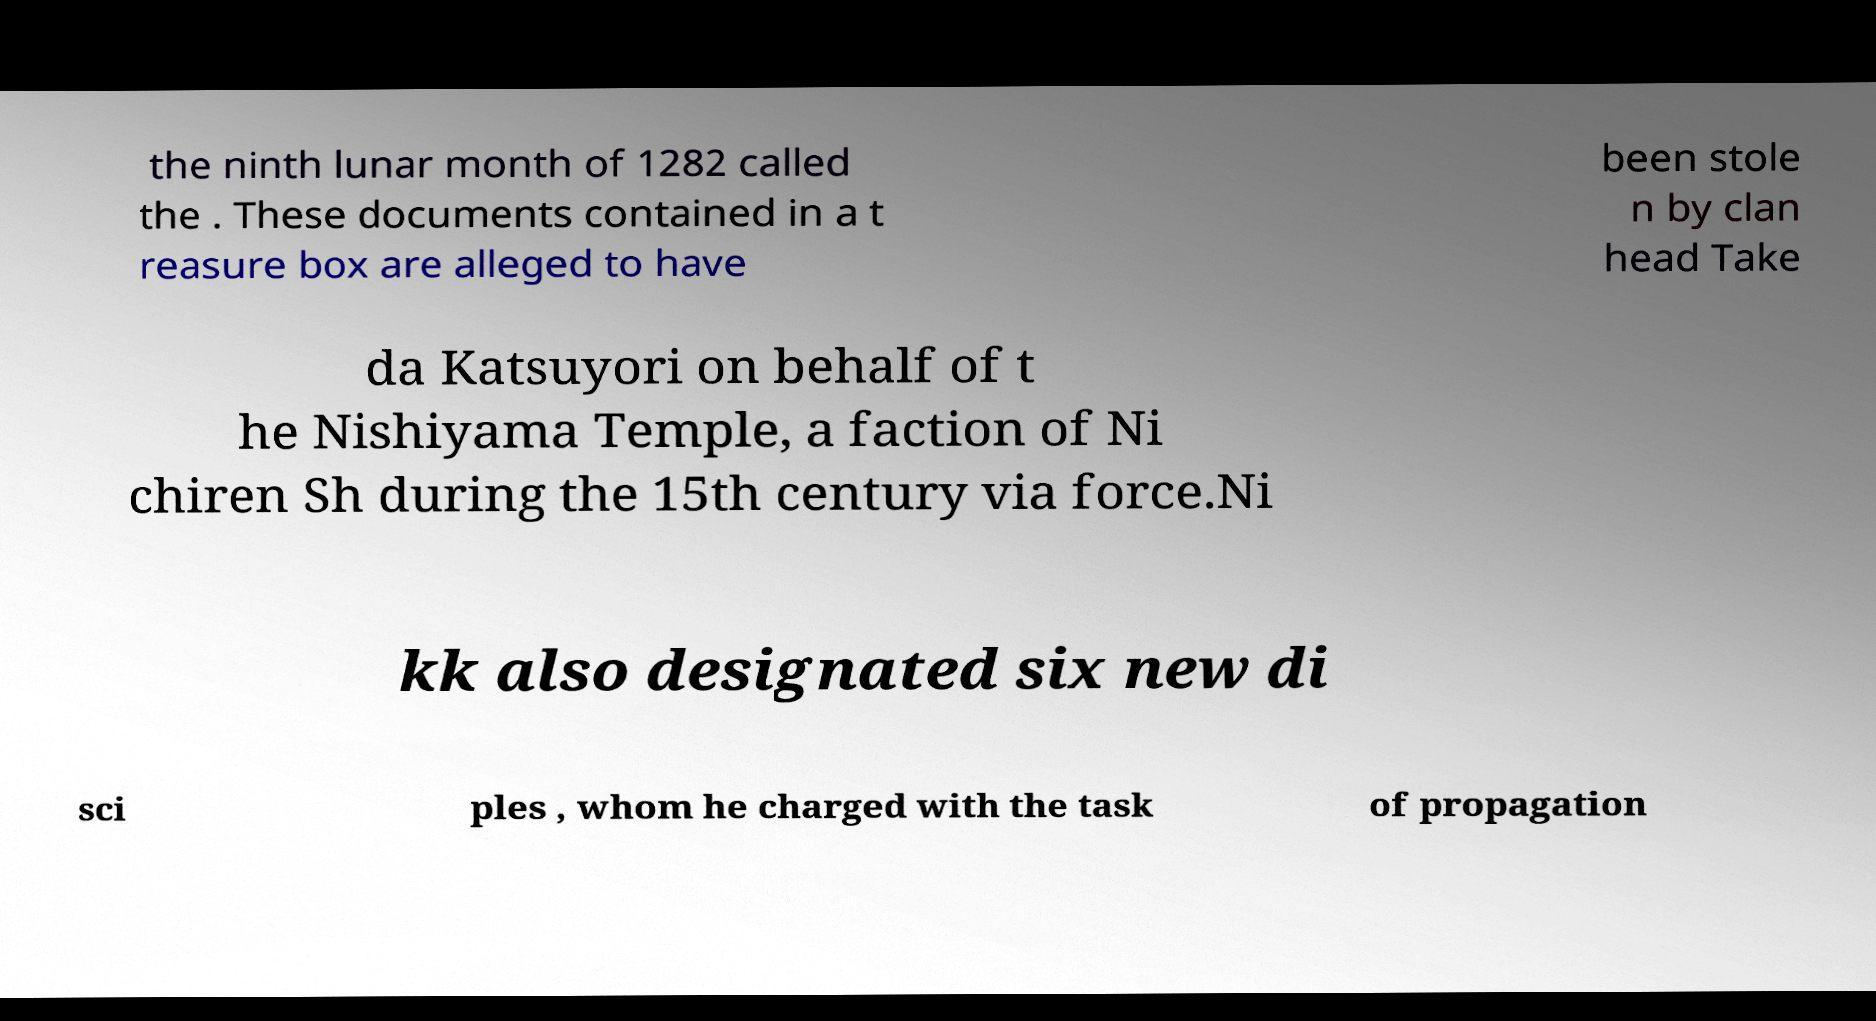Could you assist in decoding the text presented in this image and type it out clearly? the ninth lunar month of 1282 called the . These documents contained in a t reasure box are alleged to have been stole n by clan head Take da Katsuyori on behalf of t he Nishiyama Temple, a faction of Ni chiren Sh during the 15th century via force.Ni kk also designated six new di sci ples , whom he charged with the task of propagation 